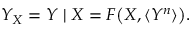Convert formula to latex. <formula><loc_0><loc_0><loc_500><loc_500>Y _ { X } = Y | X = F \left ( X , \langle Y ^ { n } \rangle \right ) .</formula> 